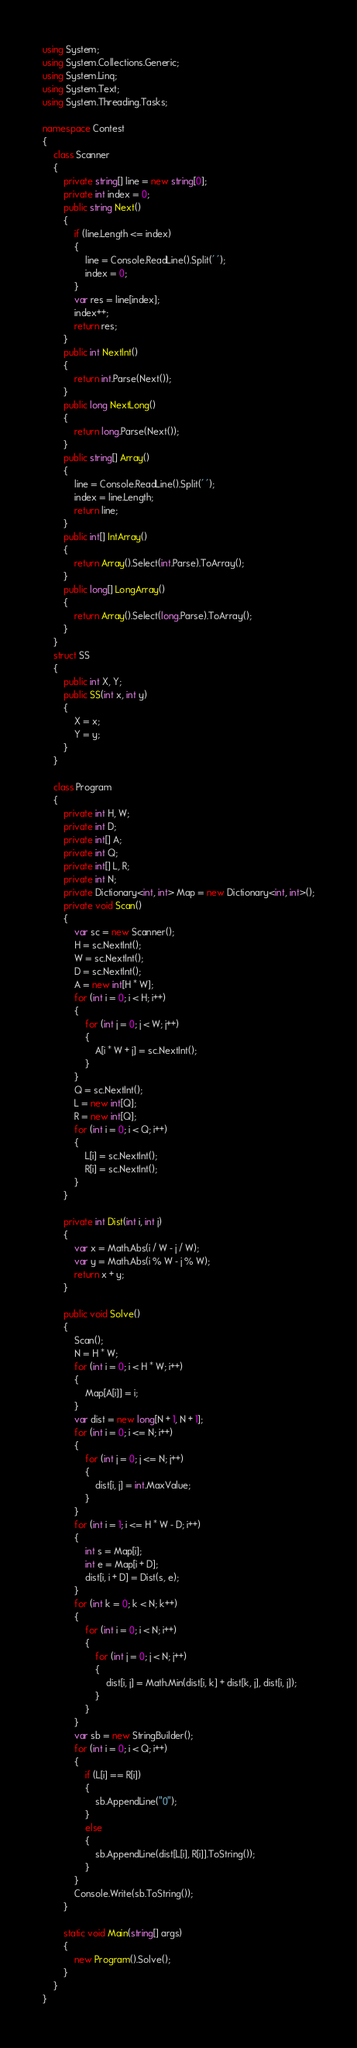<code> <loc_0><loc_0><loc_500><loc_500><_C#_>using System;
using System.Collections.Generic;
using System.Linq;
using System.Text;
using System.Threading.Tasks;

namespace Contest
{
    class Scanner
    {
        private string[] line = new string[0];
        private int index = 0;
        public string Next()
        {
            if (line.Length <= index)
            {
                line = Console.ReadLine().Split(' ');
                index = 0;
            }
            var res = line[index];
            index++;
            return res;
        }
        public int NextInt()
        {
            return int.Parse(Next());
        }
        public long NextLong()
        {
            return long.Parse(Next());
        }
        public string[] Array()
        {
            line = Console.ReadLine().Split(' ');
            index = line.Length;
            return line;
        }
        public int[] IntArray()
        {
            return Array().Select(int.Parse).ToArray();
        }
        public long[] LongArray()
        {
            return Array().Select(long.Parse).ToArray();
        }
    }
    struct SS
    {
        public int X, Y;
        public SS(int x, int y)
        {
            X = x;
            Y = y;
        }
    }

    class Program
    {
        private int H, W;
        private int D;
        private int[] A;
        private int Q;
        private int[] L, R;
        private int N;
        private Dictionary<int, int> Map = new Dictionary<int, int>();
        private void Scan()
        {
            var sc = new Scanner();
            H = sc.NextInt();
            W = sc.NextInt();
            D = sc.NextInt();
            A = new int[H * W];
            for (int i = 0; i < H; i++)
            {
                for (int j = 0; j < W; j++)
                {
                    A[i * W + j] = sc.NextInt();
                }
            }
            Q = sc.NextInt();
            L = new int[Q];
            R = new int[Q];
            for (int i = 0; i < Q; i++)
            {
                L[i] = sc.NextInt();
                R[i] = sc.NextInt();
            }
        }

        private int Dist(int i, int j)
        {
            var x = Math.Abs(i / W - j / W);
            var y = Math.Abs(i % W - j % W);
            return x + y;
        }

        public void Solve()
        {
            Scan();
            N = H * W;
            for (int i = 0; i < H * W; i++)
            {
                Map[A[i]] = i;
            }
            var dist = new long[N + 1, N + 1];
            for (int i = 0; i <= N; i++)
            {
                for (int j = 0; j <= N; j++)
                {
                    dist[i, j] = int.MaxValue;
                }
            }
            for (int i = 1; i <= H * W - D; i++)
            {
                int s = Map[i];
                int e = Map[i + D];
                dist[i, i + D] = Dist(s, e);
            }
            for (int k = 0; k < N; k++)
            {
                for (int i = 0; i < N; i++)
                {
                    for (int j = 0; j < N; j++)
                    {
                        dist[i, j] = Math.Min(dist[i, k] + dist[k, j], dist[i, j]);
                    }
                }
            }
            var sb = new StringBuilder();
            for (int i = 0; i < Q; i++)
            {
                if (L[i] == R[i])
                {
                    sb.AppendLine("0");
                }
                else
                {
                    sb.AppendLine(dist[L[i], R[i]].ToString());
                }
            }
            Console.Write(sb.ToString());
        }

        static void Main(string[] args)
        {
            new Program().Solve();
        }
    }
}</code> 